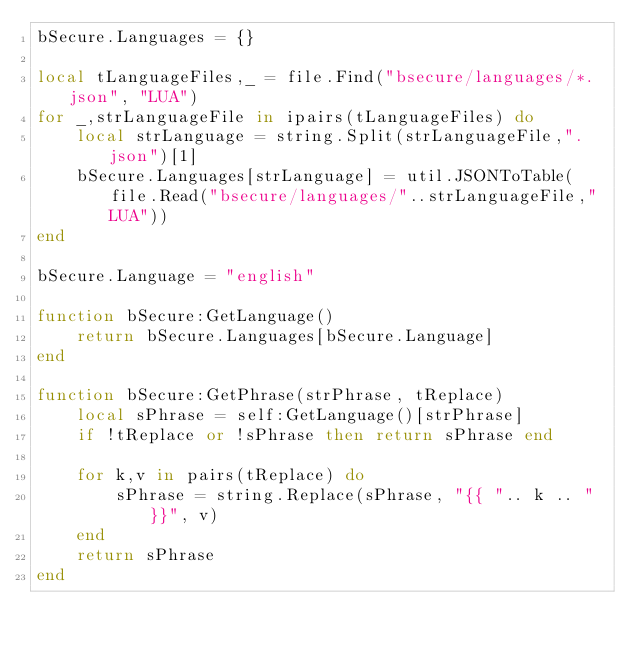<code> <loc_0><loc_0><loc_500><loc_500><_Lua_>bSecure.Languages = {}

local tLanguageFiles,_ = file.Find("bsecure/languages/*.json", "LUA")
for _,strLanguageFile in ipairs(tLanguageFiles) do
    local strLanguage = string.Split(strLanguageFile,".json")[1]
    bSecure.Languages[strLanguage] = util.JSONToTable(file.Read("bsecure/languages/"..strLanguageFile,"LUA"))
end

bSecure.Language = "english"

function bSecure:GetLanguage()
    return bSecure.Languages[bSecure.Language]
end

function bSecure:GetPhrase(strPhrase, tReplace)
    local sPhrase = self:GetLanguage()[strPhrase]
    if !tReplace or !sPhrase then return sPhrase end

    for k,v in pairs(tReplace) do
        sPhrase = string.Replace(sPhrase, "{{ ".. k .. " }}", v)
    end
    return sPhrase
end </code> 